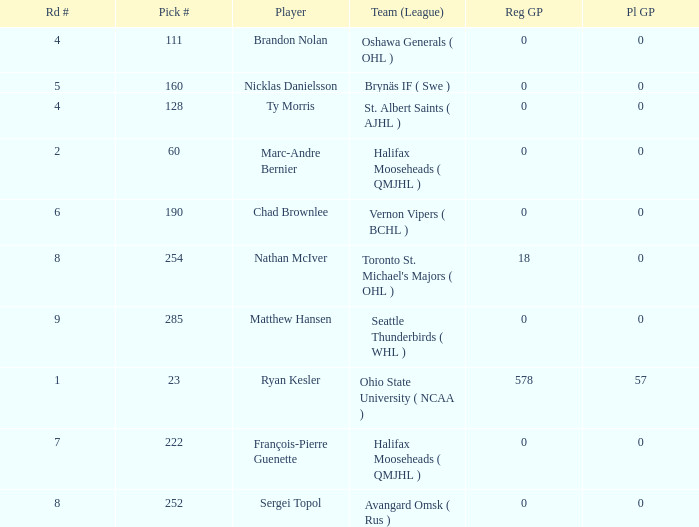What's the highest Pl GP with a Reg GP over 18? 57.0. 